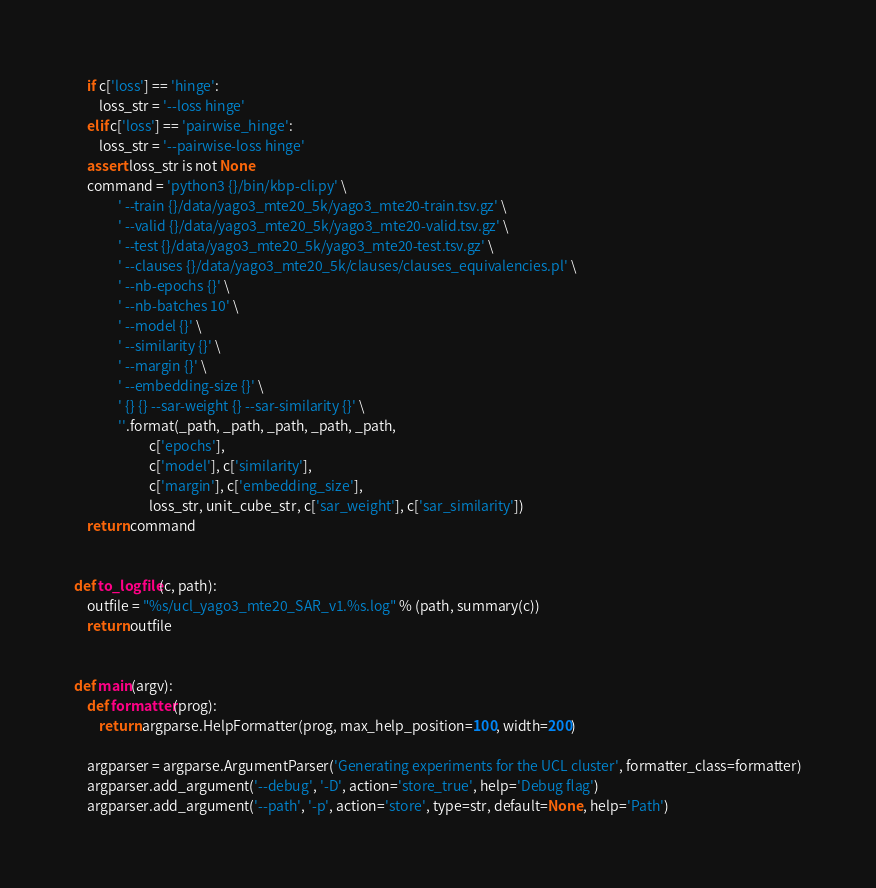Convert code to text. <code><loc_0><loc_0><loc_500><loc_500><_Python_>    if c['loss'] == 'hinge':
        loss_str = '--loss hinge'
    elif c['loss'] == 'pairwise_hinge':
        loss_str = '--pairwise-loss hinge'
    assert loss_str is not None
    command = 'python3 {}/bin/kbp-cli.py' \
              ' --train {}/data/yago3_mte20_5k/yago3_mte20-train.tsv.gz' \
              ' --valid {}/data/yago3_mte20_5k/yago3_mte20-valid.tsv.gz' \
              ' --test {}/data/yago3_mte20_5k/yago3_mte20-test.tsv.gz' \
              ' --clauses {}/data/yago3_mte20_5k/clauses/clauses_equivalencies.pl' \
              ' --nb-epochs {}' \
              ' --nb-batches 10' \
              ' --model {}' \
              ' --similarity {}' \
              ' --margin {}' \
              ' --embedding-size {}' \
              ' {} {} --sar-weight {} --sar-similarity {}' \
              ''.format(_path, _path, _path, _path, _path,
                        c['epochs'],
                        c['model'], c['similarity'],
                        c['margin'], c['embedding_size'],
                        loss_str, unit_cube_str, c['sar_weight'], c['sar_similarity'])
    return command


def to_logfile(c, path):
    outfile = "%s/ucl_yago3_mte20_SAR_v1.%s.log" % (path, summary(c))
    return outfile


def main(argv):
    def formatter(prog):
        return argparse.HelpFormatter(prog, max_help_position=100, width=200)

    argparser = argparse.ArgumentParser('Generating experiments for the UCL cluster', formatter_class=formatter)
    argparser.add_argument('--debug', '-D', action='store_true', help='Debug flag')
    argparser.add_argument('--path', '-p', action='store', type=str, default=None, help='Path')
</code> 